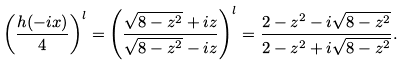<formula> <loc_0><loc_0><loc_500><loc_500>\left ( \frac { h ( - i x ) } { 4 } \right ) ^ { l } = \left ( \frac { \sqrt { 8 - z ^ { 2 } } + i z } { \sqrt { 8 - z ^ { 2 } } - i z } \right ) ^ { l } = \frac { 2 - z ^ { 2 } - i \sqrt { 8 - z ^ { 2 } } } { 2 - z ^ { 2 } + i \sqrt { 8 - z ^ { 2 } } } .</formula> 